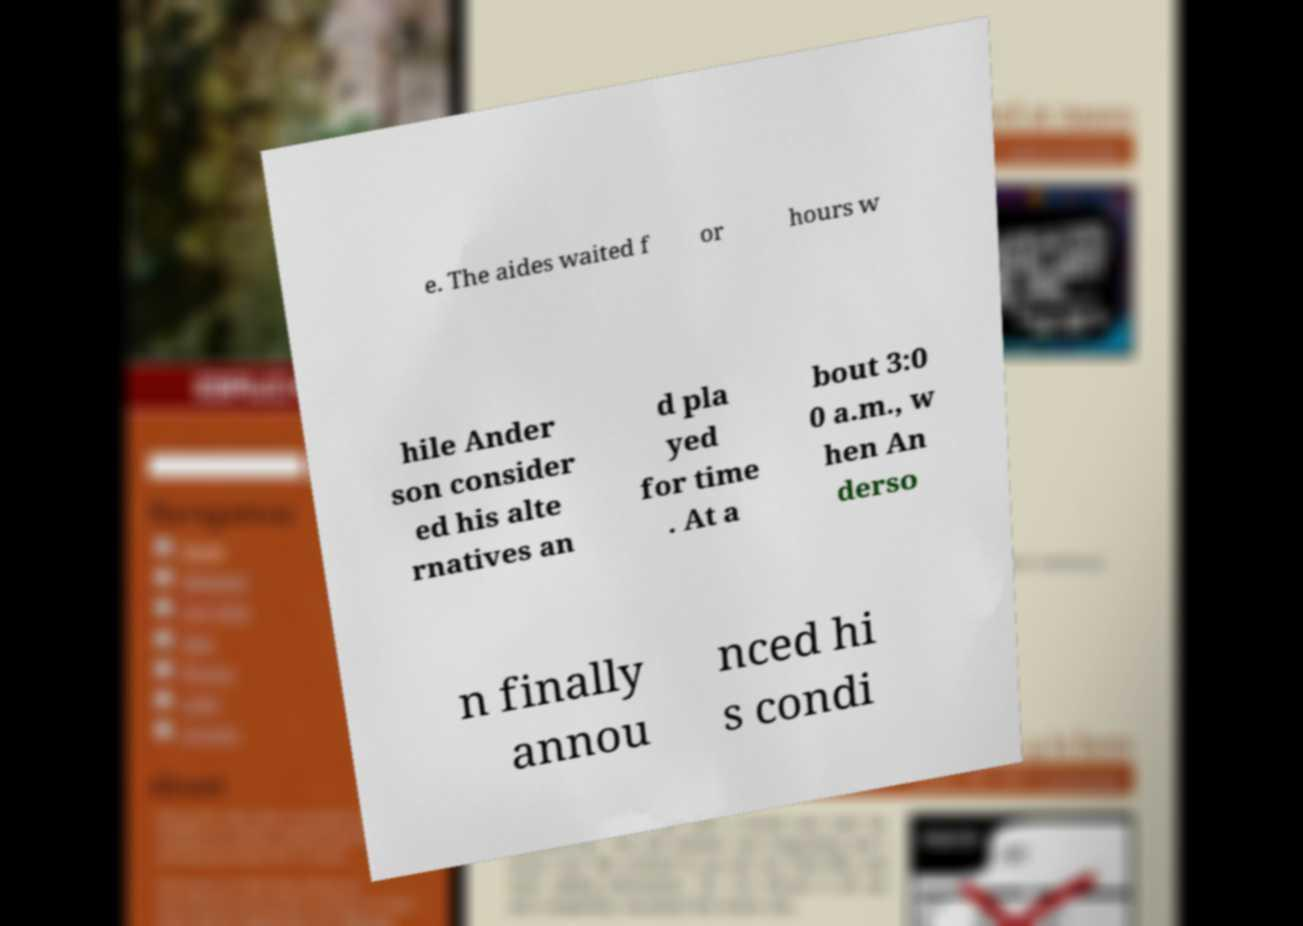Can you read and provide the text displayed in the image?This photo seems to have some interesting text. Can you extract and type it out for me? e. The aides waited f or hours w hile Ander son consider ed his alte rnatives an d pla yed for time . At a bout 3:0 0 a.m., w hen An derso n finally annou nced hi s condi 